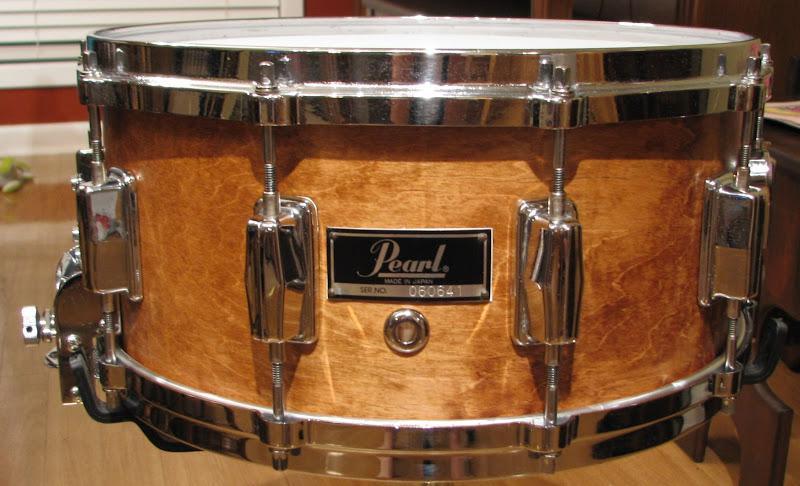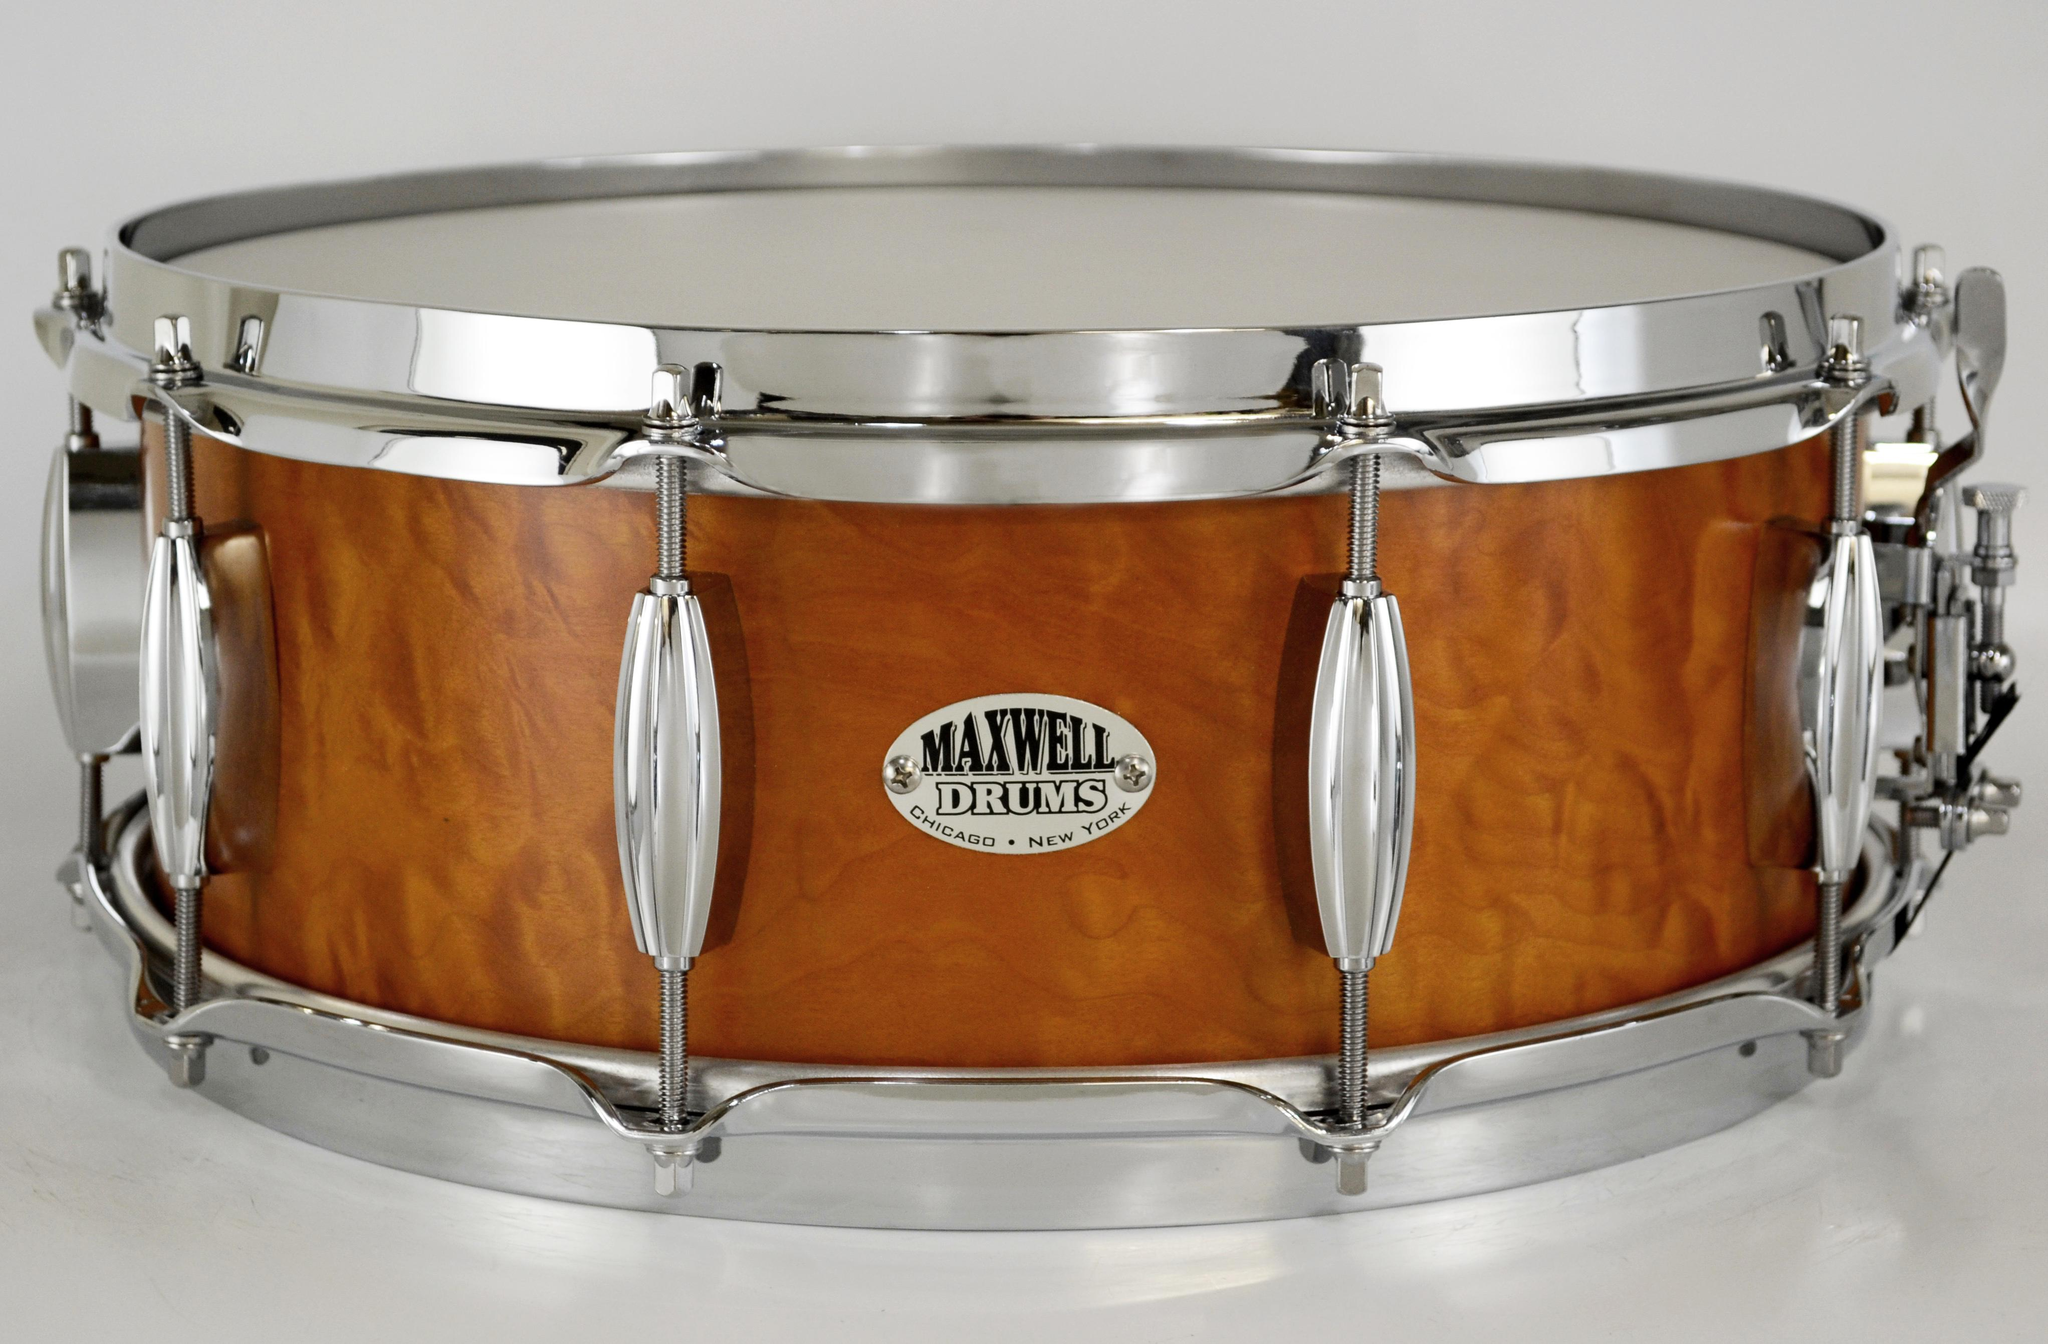The first image is the image on the left, the second image is the image on the right. Considering the images on both sides, is "All drums are lying flat and one drum has an oval label that is facing directly forward." valid? Answer yes or no. Yes. The first image is the image on the left, the second image is the image on the right. Given the left and right images, does the statement "One drum contains a silver, oval shaped brand label on the side." hold true? Answer yes or no. Yes. 